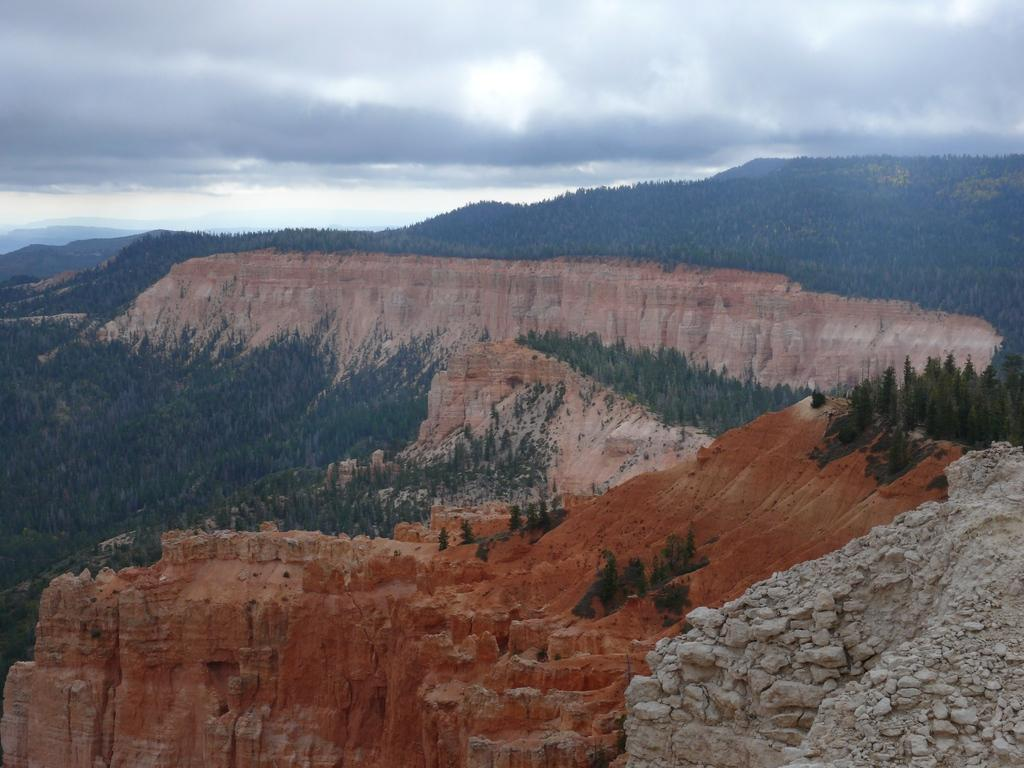What type of landscape feature is present in the image? There is a mountain in the image. What type of vegetation can be seen in the image? There are trees in the image. What is visible at the top of the image? The sky is visible at the top of the image. How many beginner skiers can be seen in the image? There are no skiers, beginner or otherwise, present in the image. What type of flock is visible in the image? There is no flock of animals or birds present in the image. 